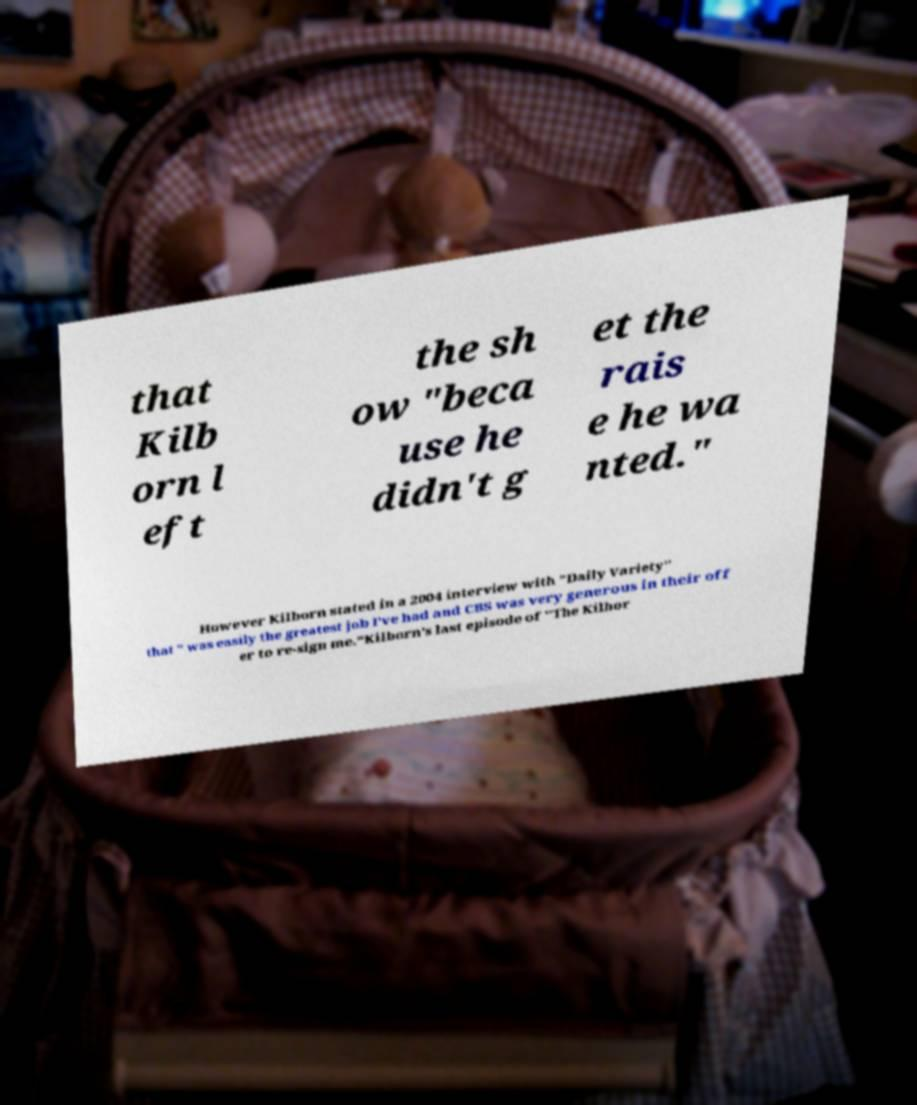For documentation purposes, I need the text within this image transcribed. Could you provide that? that Kilb orn l eft the sh ow "beca use he didn't g et the rais e he wa nted." However Kilborn stated in a 2004 interview with "Daily Variety" that " was easily the greatest job I've had and CBS was very generous in their off er to re-sign me."Kilborn's last episode of "The Kilbor 